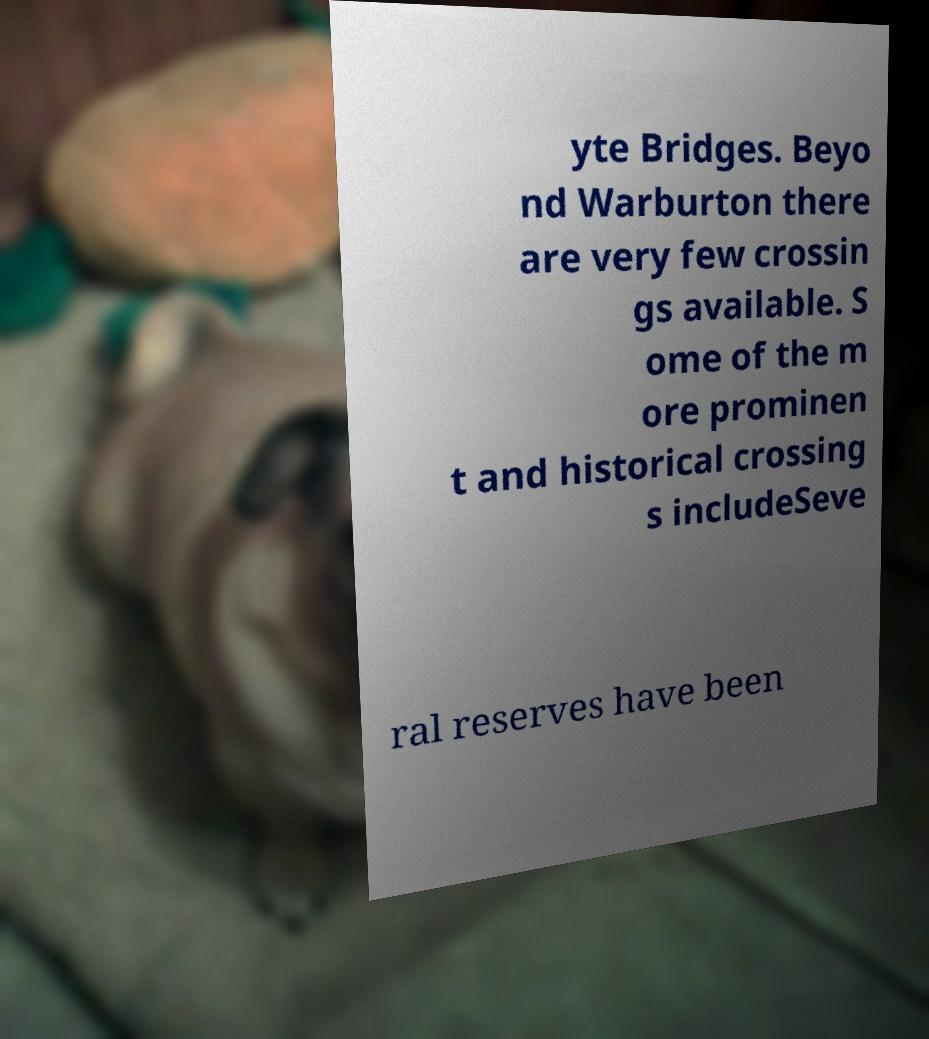Can you accurately transcribe the text from the provided image for me? yte Bridges. Beyo nd Warburton there are very few crossin gs available. S ome of the m ore prominen t and historical crossing s includeSeve ral reserves have been 